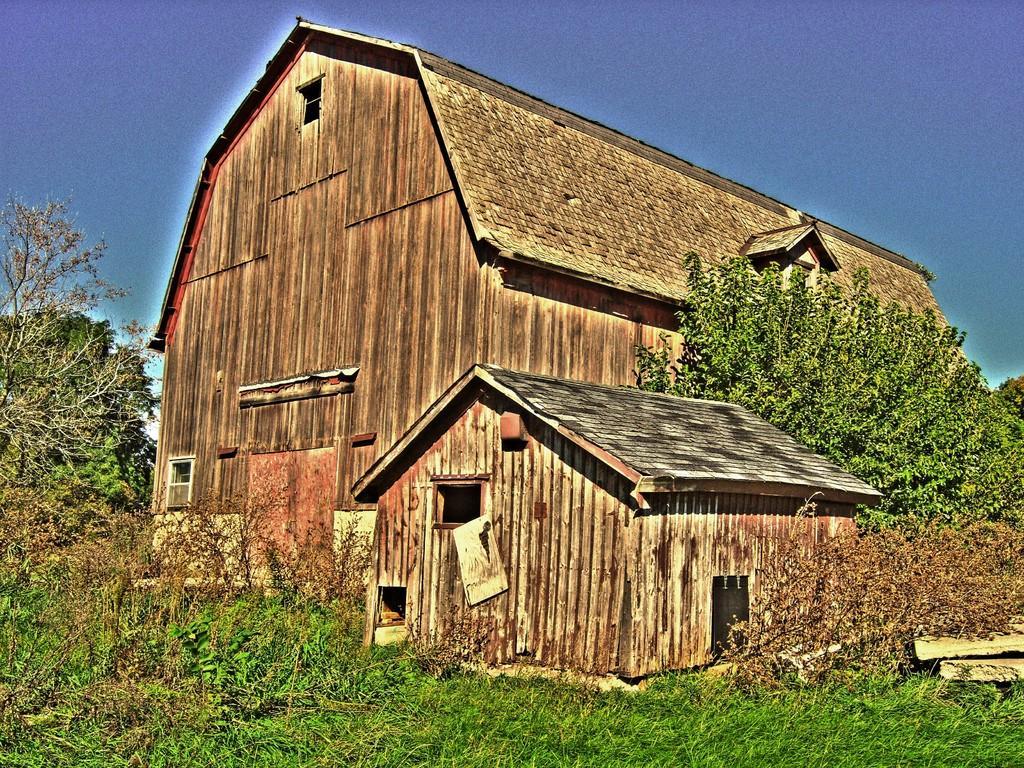In one or two sentences, can you explain what this image depicts? This is a painting and here we can see sheds, trees, logs and some plants. At the top, there is sky. 